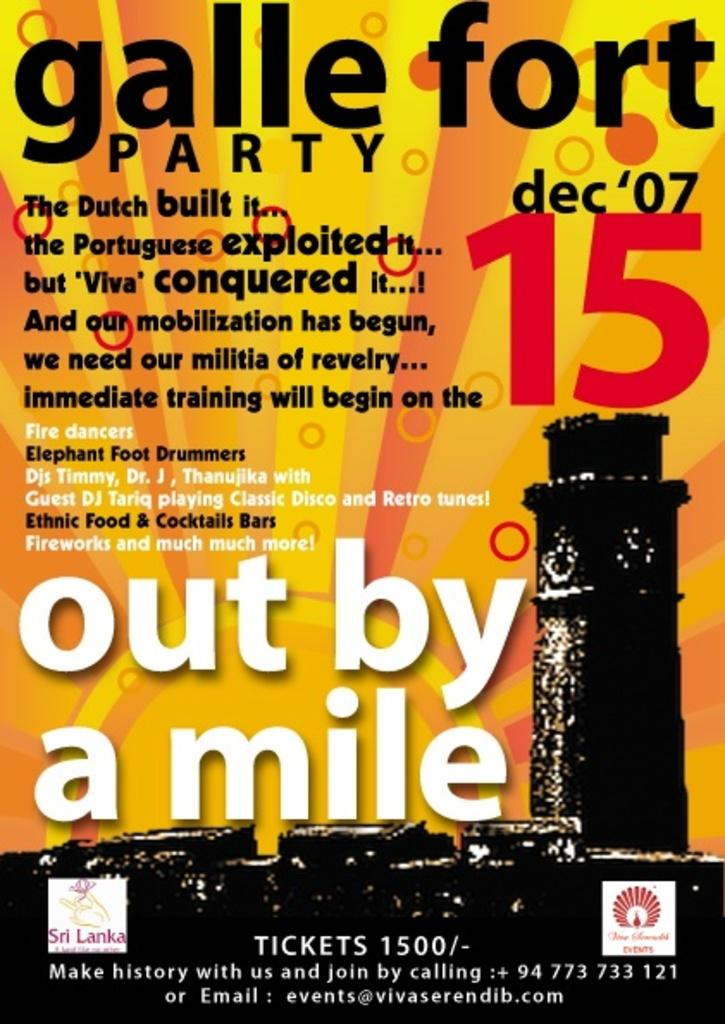<image>
Render a clear and concise summary of the photo. yellow and orange poster for galle forte party on dec 7, 2015 